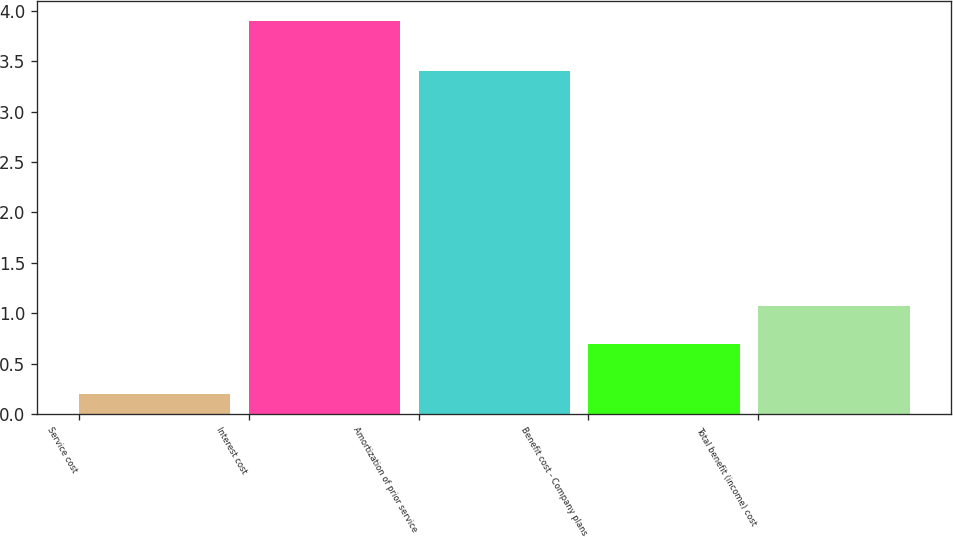<chart> <loc_0><loc_0><loc_500><loc_500><bar_chart><fcel>Service cost<fcel>Interest cost<fcel>Amortization of prior service<fcel>Benefit cost - Company plans<fcel>Total benefit (income) cost<nl><fcel>0.2<fcel>3.9<fcel>3.4<fcel>0.7<fcel>1.07<nl></chart> 